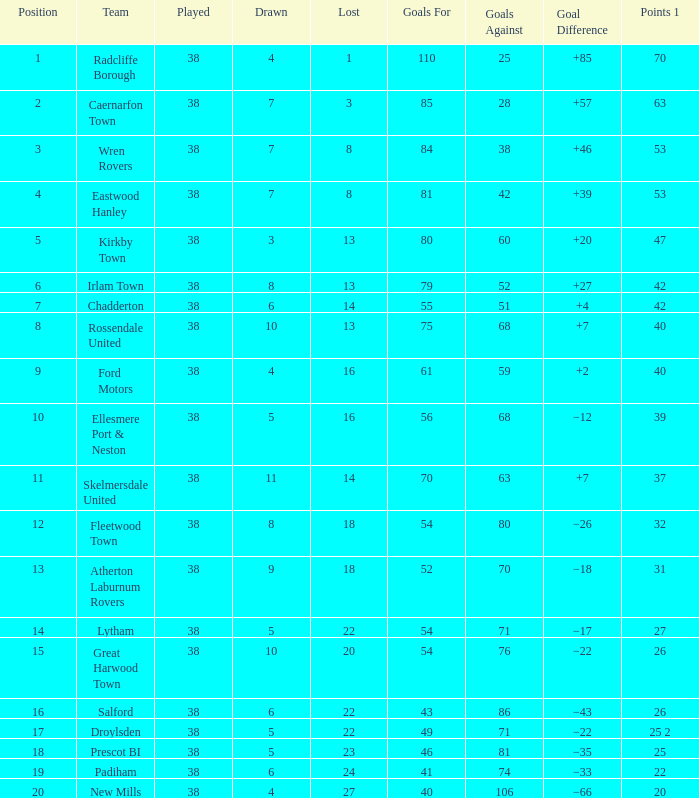Which Lost has a Position larger than 5, and Points 1 of 37, and less than 63 Goals Against? None. 